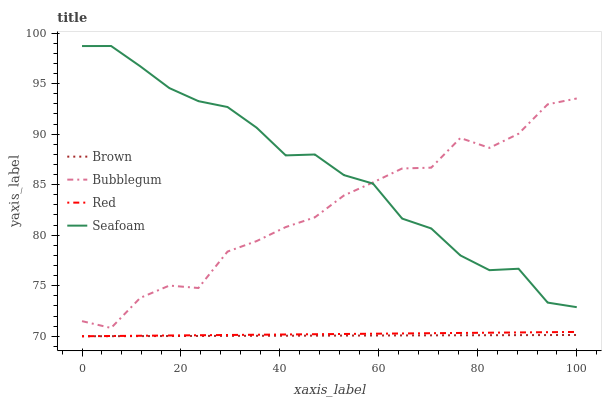Does Brown have the minimum area under the curve?
Answer yes or no. Yes. Does Seafoam have the maximum area under the curve?
Answer yes or no. Yes. Does Red have the minimum area under the curve?
Answer yes or no. No. Does Red have the maximum area under the curve?
Answer yes or no. No. Is Brown the smoothest?
Answer yes or no. Yes. Is Bubblegum the roughest?
Answer yes or no. Yes. Is Red the smoothest?
Answer yes or no. No. Is Red the roughest?
Answer yes or no. No. Does Brown have the lowest value?
Answer yes or no. Yes. Does Bubblegum have the lowest value?
Answer yes or no. No. Does Seafoam have the highest value?
Answer yes or no. Yes. Does Red have the highest value?
Answer yes or no. No. Is Brown less than Bubblegum?
Answer yes or no. Yes. Is Seafoam greater than Brown?
Answer yes or no. Yes. Does Brown intersect Red?
Answer yes or no. Yes. Is Brown less than Red?
Answer yes or no. No. Is Brown greater than Red?
Answer yes or no. No. Does Brown intersect Bubblegum?
Answer yes or no. No. 